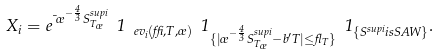<formula> <loc_0><loc_0><loc_500><loc_500>X _ { i } = e ^ { \mu \sigma ^ { - \frac { 4 } { 3 } } S ^ { s u p { i } } _ { T _ { \sigma } } } \ 1 _ { \ e v _ { i } ( \delta , T , \sigma ) } \ 1 _ { \{ | \sigma ^ { - \frac { 4 } { 3 } } S ^ { s u p { i } } _ { T _ { \sigma } } - b ^ { \prime } T | \leq \gamma _ { T } \} } \ 1 _ { \{ S ^ { s u p { i } } { i s S A W } \} } .</formula> 